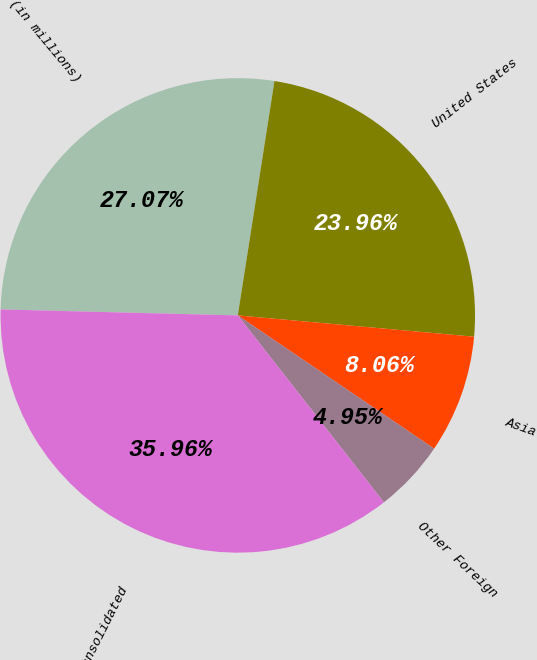Convert chart. <chart><loc_0><loc_0><loc_500><loc_500><pie_chart><fcel>(in millions)<fcel>United States<fcel>Asia<fcel>Other Foreign<fcel>Consolidated<nl><fcel>27.07%<fcel>23.96%<fcel>8.06%<fcel>4.95%<fcel>35.96%<nl></chart> 